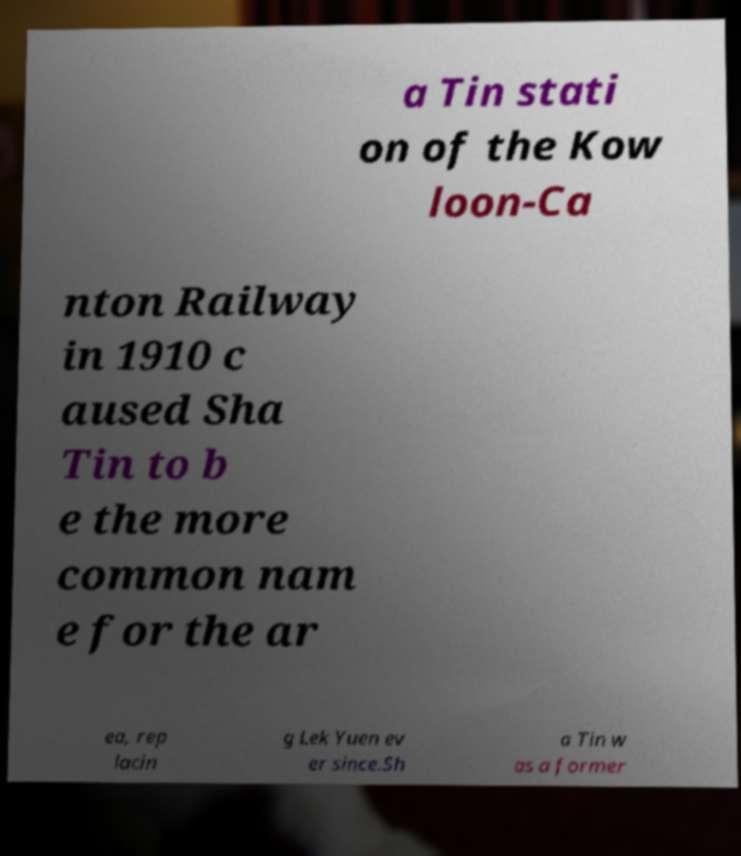There's text embedded in this image that I need extracted. Can you transcribe it verbatim? a Tin stati on of the Kow loon-Ca nton Railway in 1910 c aused Sha Tin to b e the more common nam e for the ar ea, rep lacin g Lek Yuen ev er since.Sh a Tin w as a former 